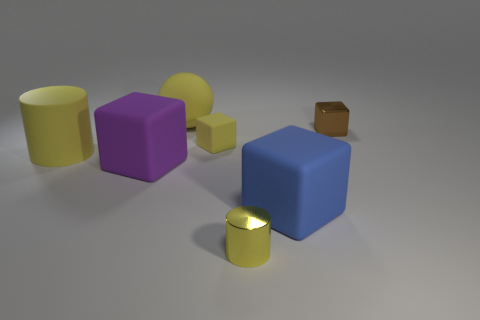There is a blue object that is the same shape as the tiny brown shiny object; what material is it?
Offer a terse response. Rubber. What is the material of the large thing behind the big yellow object in front of the matte ball?
Your answer should be very brief. Rubber. How many blue things are spheres or things?
Ensure brevity in your answer.  1. Is the shape of the brown metallic object the same as the big purple matte thing?
Ensure brevity in your answer.  Yes. Are there any yellow things in front of the large rubber cube to the right of the tiny yellow rubber block?
Ensure brevity in your answer.  Yes. Are there the same number of small yellow matte things that are in front of the large rubber sphere and small yellow metal objects?
Make the answer very short. Yes. How many other objects are there of the same size as the brown block?
Give a very brief answer. 2. Does the big block that is on the left side of the yellow rubber ball have the same material as the small block in front of the brown metal thing?
Make the answer very short. Yes. There is a rubber thing behind the brown block that is in front of the large yellow matte ball; what is its size?
Your answer should be compact. Large. Is there a small rubber sphere of the same color as the small cylinder?
Offer a terse response. No. 